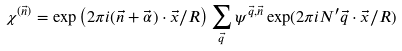<formula> <loc_0><loc_0><loc_500><loc_500>\chi ^ { ( \vec { n } ) } = \exp \left ( 2 \pi i ( \vec { n } + \vec { \alpha } ) \cdot \vec { x } / R \right ) \sum _ { \vec { q } } \psi ^ { \vec { q } , \vec { n } } \exp ( 2 \pi i N ^ { \prime } \vec { q } \cdot \vec { x } / R )</formula> 